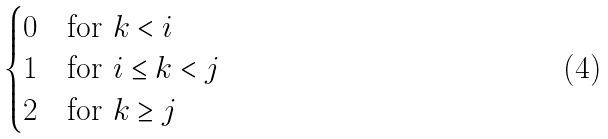<formula> <loc_0><loc_0><loc_500><loc_500>\begin{cases} 0 & \text {for $k<i$} \\ 1 & \text {for $i\leq k<j$} \\ 2 & \text {for $k\geq j$} \end{cases}</formula> 